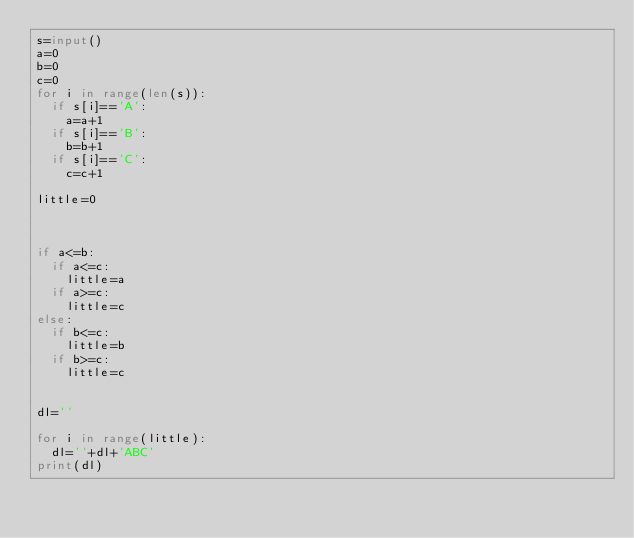Convert code to text. <code><loc_0><loc_0><loc_500><loc_500><_Python_>s=input()
a=0
b=0
c=0
for i in range(len(s)):
	if s[i]=='A':
		a=a+1
	if s[i]=='B':
		b=b+1
	if s[i]=='C':
		c=c+1

little=0



if a<=b:
	if a<=c:
		little=a
	if a>=c:
		little=c
else:
	if b<=c:
		little=b
	if b>=c:
		little=c


dl=''

for i in range(little):
	dl=''+dl+'ABC'
print(dl)</code> 